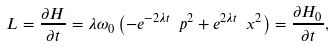<formula> <loc_0><loc_0><loc_500><loc_500>L = \frac { \partial H } { \partial t } = \lambda \omega _ { 0 } \left ( - e ^ { - 2 \lambda t } \ p ^ { 2 } + e ^ { 2 \lambda t } \ x ^ { 2 } \right ) = \frac { \partial H _ { 0 } } { \partial t } ,</formula> 